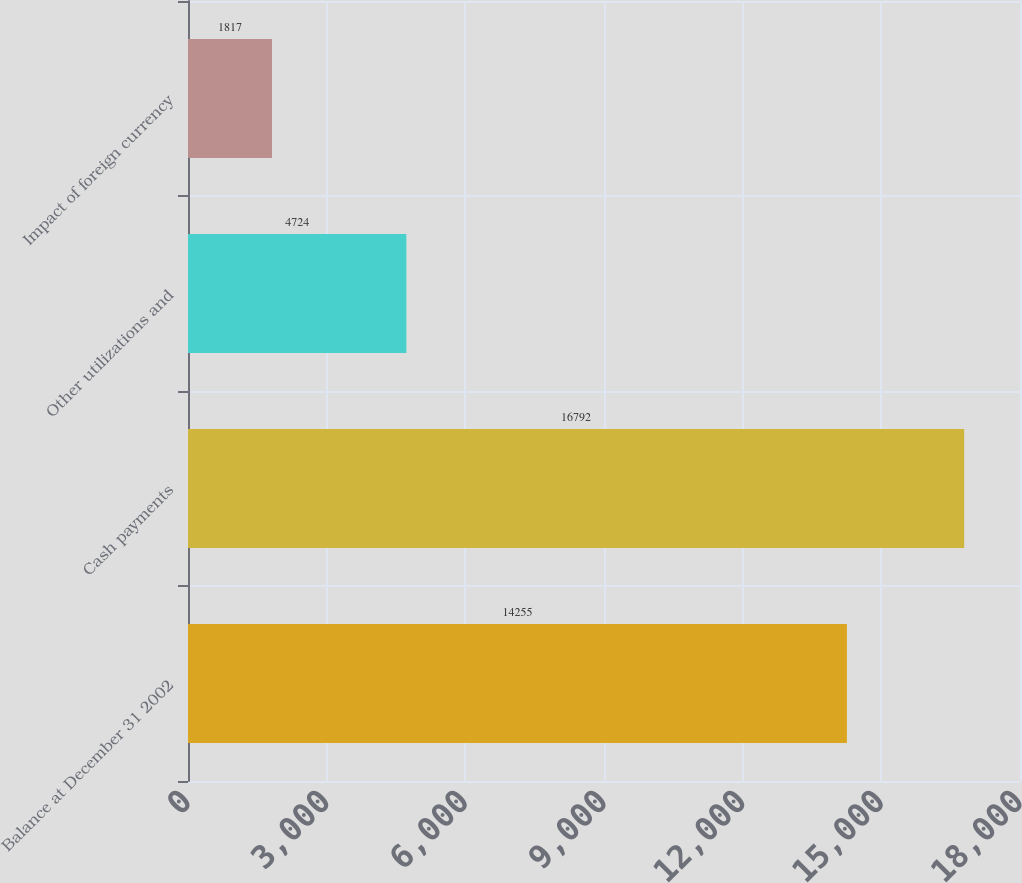<chart> <loc_0><loc_0><loc_500><loc_500><bar_chart><fcel>Balance at December 31 2002<fcel>Cash payments<fcel>Other utilizations and<fcel>Impact of foreign currency<nl><fcel>14255<fcel>16792<fcel>4724<fcel>1817<nl></chart> 